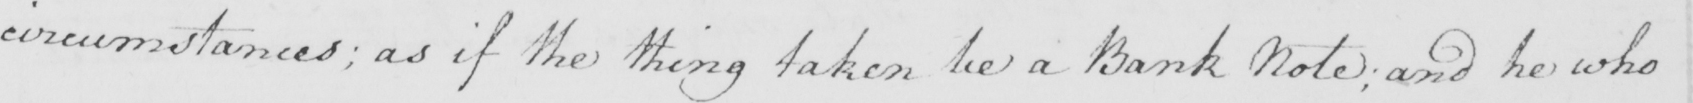Please provide the text content of this handwritten line. circumstances ; as if the thing taken be a Bank Note  ; and he who 